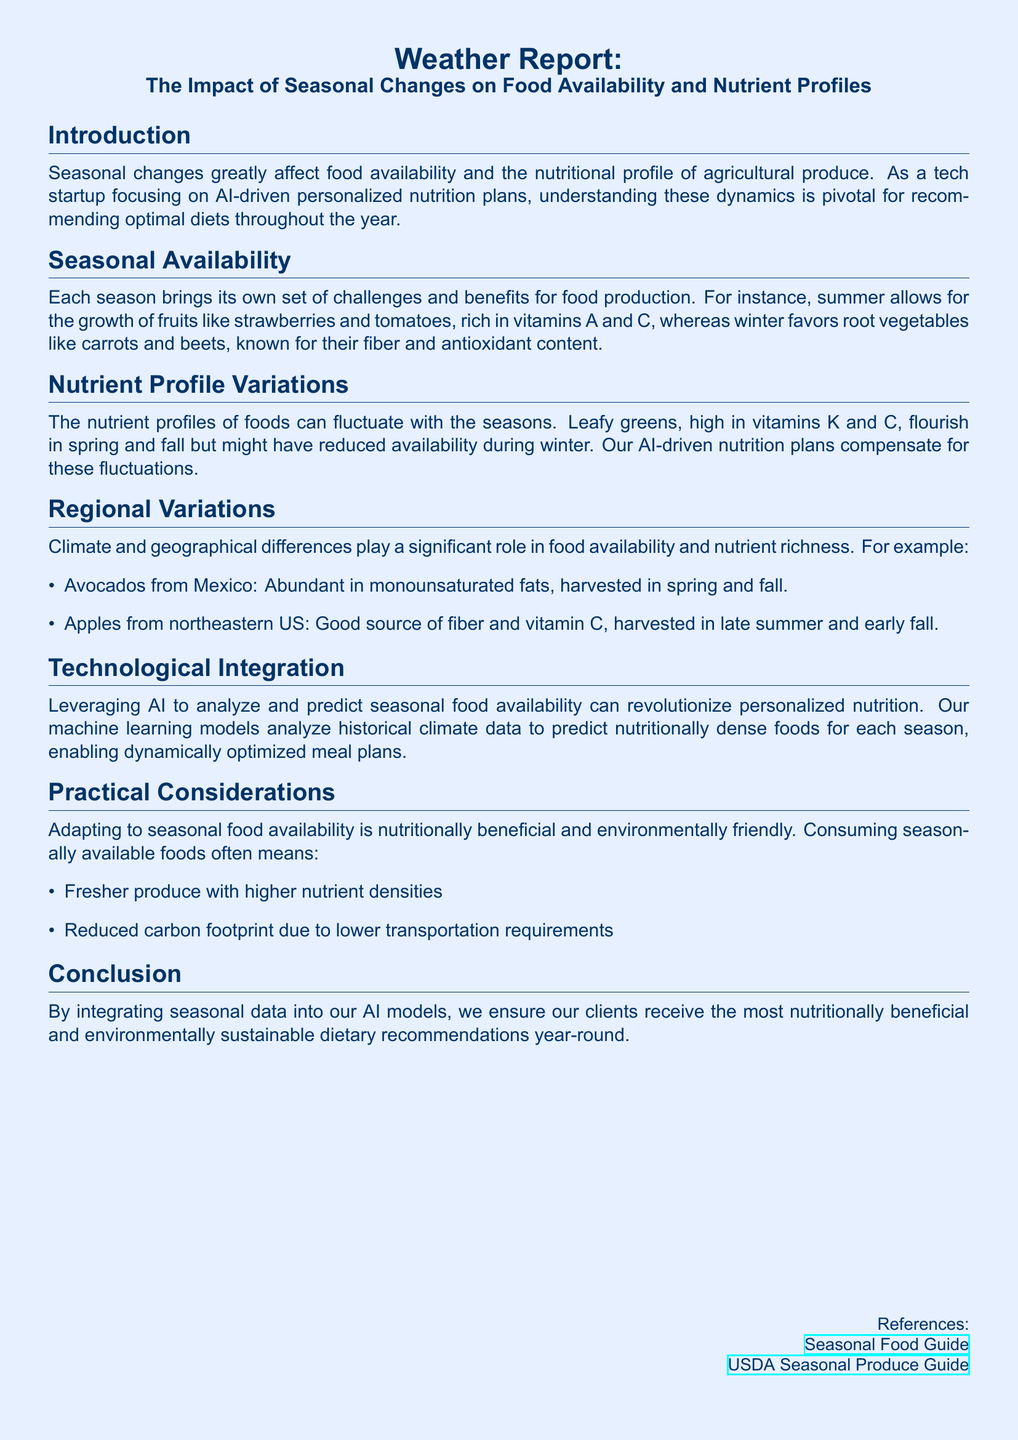What is the primary focus of the tech startup? The startup focuses on AI-driven personalized nutrition plans.
Answer: AI-driven personalized nutrition plans What seasonal fruits are mentioned as rich in vitamins A and C? The document mentions strawberries and tomatoes as fruits rich in vitamins A and C during summer.
Answer: Strawberries and tomatoes Which vegetables are highlighted for winter? The root vegetables carrots and beets are mentioned as favored during winter for their fiber and antioxidant content.
Answer: Carrots and beets In which seasons do leafy greens flourish? Leafy greens are noted to flourish in spring and fall but may have reduced availability in winter.
Answer: Spring and fall What is a benefit of consuming seasonally available foods? The document states that consuming seasonally available foods leads to fresher produce with higher nutrient densities.
Answer: Fresher produce with higher nutrient densities What role do climate and geographical differences play? Climate and geographical differences significantly influence food availability and nutrient richness.
Answer: Food availability and nutrient richness How can AI help in personalized nutrition plans? AI analyzes historical climate data to predict nutritionally dense foods for each season.
Answer: Predict nutritionally dense foods What are the environmental benefits mentioned? Consuming seasonally available foods can reduce carbon footprint due to lower transportation requirements.
Answer: Reduced carbon footprint 